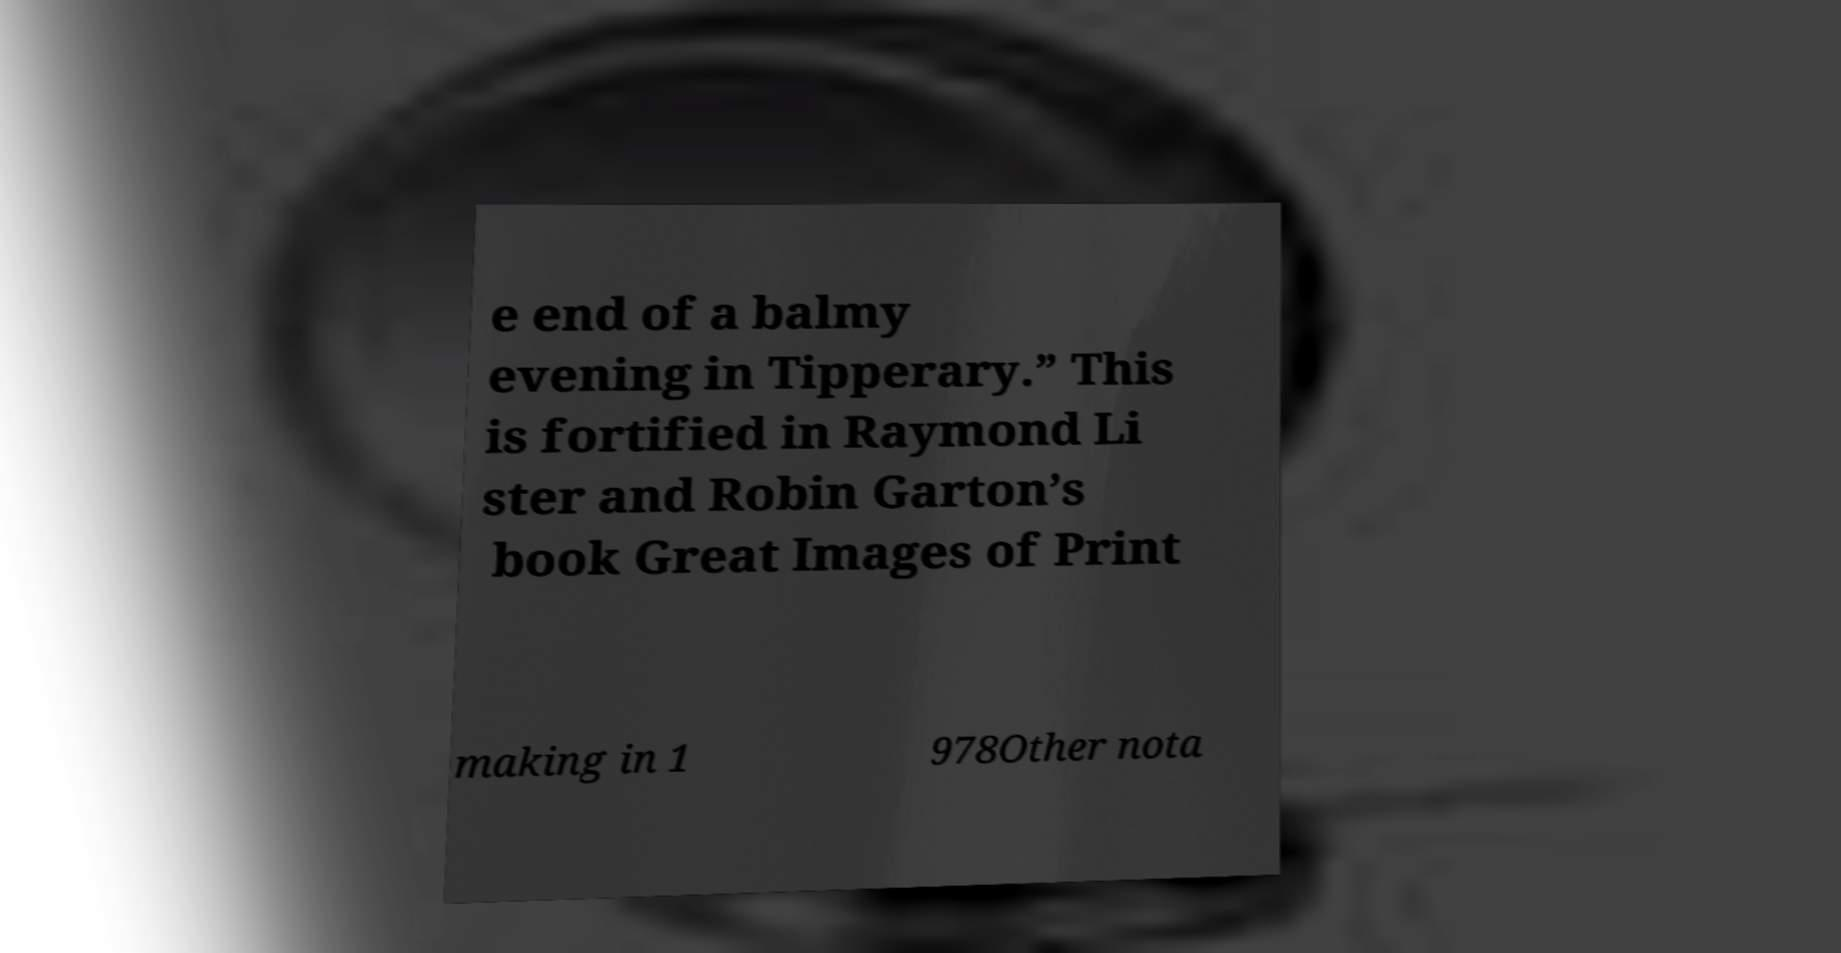Can you read and provide the text displayed in the image?This photo seems to have some interesting text. Can you extract and type it out for me? e end of a balmy evening in Tipperary.” This is fortified in Raymond Li ster and Robin Garton’s book Great Images of Print making in 1 978Other nota 